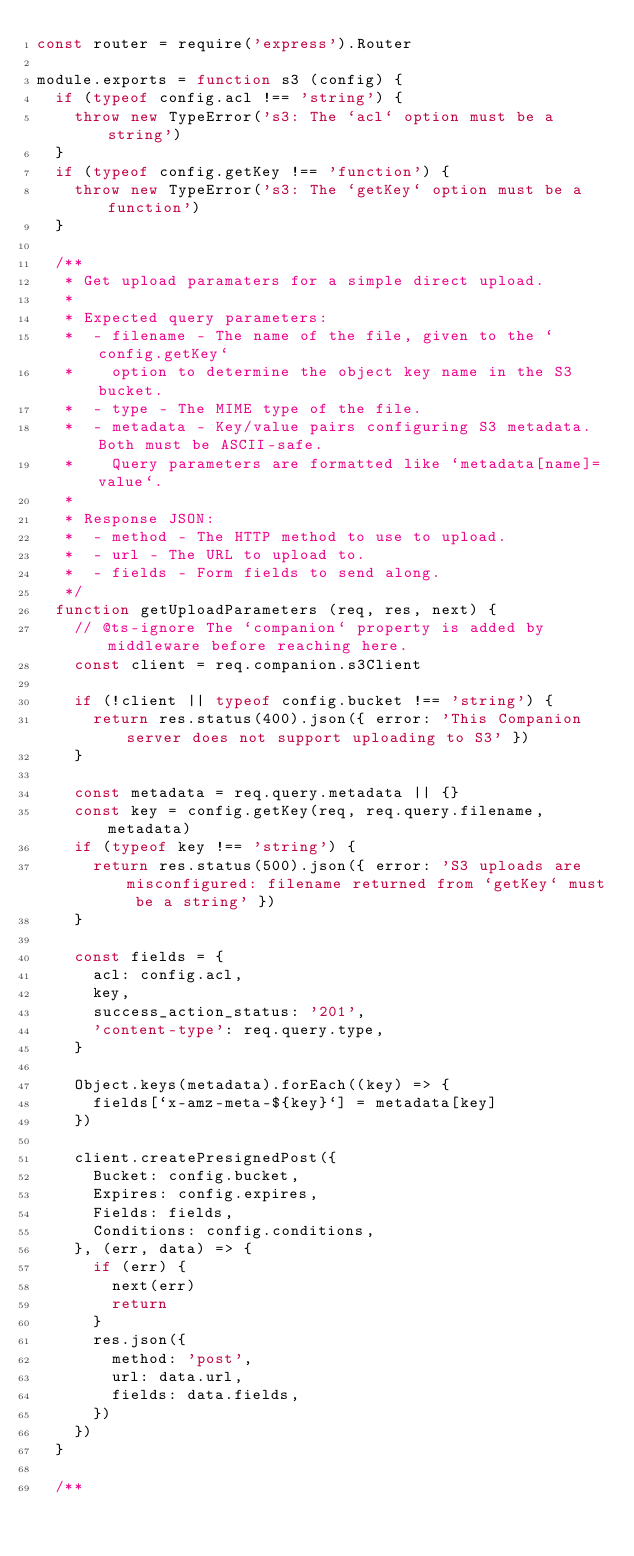<code> <loc_0><loc_0><loc_500><loc_500><_JavaScript_>const router = require('express').Router

module.exports = function s3 (config) {
  if (typeof config.acl !== 'string') {
    throw new TypeError('s3: The `acl` option must be a string')
  }
  if (typeof config.getKey !== 'function') {
    throw new TypeError('s3: The `getKey` option must be a function')
  }

  /**
   * Get upload paramaters for a simple direct upload.
   *
   * Expected query parameters:
   *  - filename - The name of the file, given to the `config.getKey`
   *    option to determine the object key name in the S3 bucket.
   *  - type - The MIME type of the file.
   *  - metadata - Key/value pairs configuring S3 metadata. Both must be ASCII-safe.
   *    Query parameters are formatted like `metadata[name]=value`.
   *
   * Response JSON:
   *  - method - The HTTP method to use to upload.
   *  - url - The URL to upload to.
   *  - fields - Form fields to send along.
   */
  function getUploadParameters (req, res, next) {
    // @ts-ignore The `companion` property is added by middleware before reaching here.
    const client = req.companion.s3Client

    if (!client || typeof config.bucket !== 'string') {
      return res.status(400).json({ error: 'This Companion server does not support uploading to S3' })
    }

    const metadata = req.query.metadata || {}
    const key = config.getKey(req, req.query.filename, metadata)
    if (typeof key !== 'string') {
      return res.status(500).json({ error: 'S3 uploads are misconfigured: filename returned from `getKey` must be a string' })
    }

    const fields = {
      acl: config.acl,
      key,
      success_action_status: '201',
      'content-type': req.query.type,
    }

    Object.keys(metadata).forEach((key) => {
      fields[`x-amz-meta-${key}`] = metadata[key]
    })

    client.createPresignedPost({
      Bucket: config.bucket,
      Expires: config.expires,
      Fields: fields,
      Conditions: config.conditions,
    }, (err, data) => {
      if (err) {
        next(err)
        return
      }
      res.json({
        method: 'post',
        url: data.url,
        fields: data.fields,
      })
    })
  }

  /**</code> 